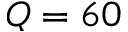Convert formula to latex. <formula><loc_0><loc_0><loc_500><loc_500>Q = 6 0</formula> 